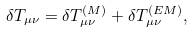Convert formula to latex. <formula><loc_0><loc_0><loc_500><loc_500>\delta T _ { \mu \nu } = \delta T _ { \mu \nu } ^ { ( M ) } + \delta T _ { \mu \nu } ^ { ( E M ) } ,</formula> 